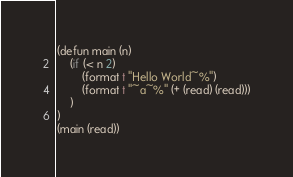Convert code to text. <code><loc_0><loc_0><loc_500><loc_500><_Lisp_>(defun main (n)
	(if (< n 2)
		(format t "Hello World~%")
		(format t "~a~%" (+ (read) (read)))
	)
)
(main (read))
</code> 